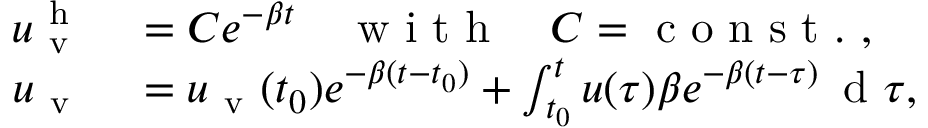Convert formula to latex. <formula><loc_0><loc_0><loc_500><loc_500>\begin{array} { r l } { u _ { v } ^ { h } } & = C e ^ { - \beta t } \quad w i t h \quad C = c o n s t . , } \\ { u _ { v } } & = u _ { v } ( t _ { 0 } ) e ^ { - \beta ( t - t _ { 0 } ) } + \int _ { t _ { 0 } } ^ { t } u ( \tau ) \beta e ^ { - \beta ( t - \tau ) } \, d \tau , } \end{array}</formula> 